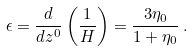<formula> <loc_0><loc_0><loc_500><loc_500>\epsilon = \frac { d } { d z ^ { 0 } } \left ( \frac { 1 } { H } \right ) = \frac { 3 \eta _ { 0 } } { 1 + \eta _ { 0 } } \, .</formula> 